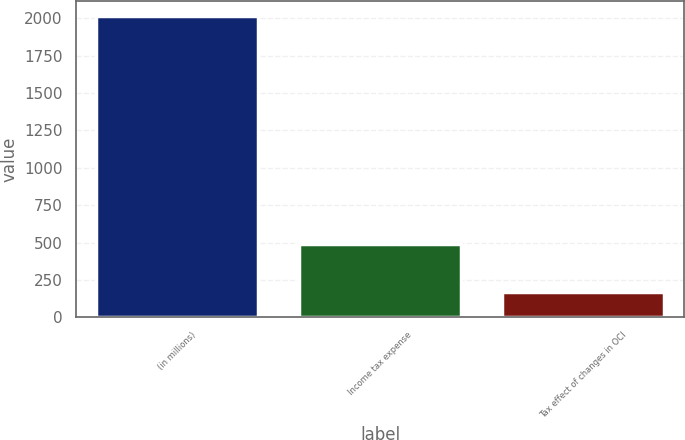<chart> <loc_0><loc_0><loc_500><loc_500><bar_chart><fcel>(in millions)<fcel>Income tax expense<fcel>Tax effect of changes in OCI<nl><fcel>2016<fcel>489<fcel>168<nl></chart> 